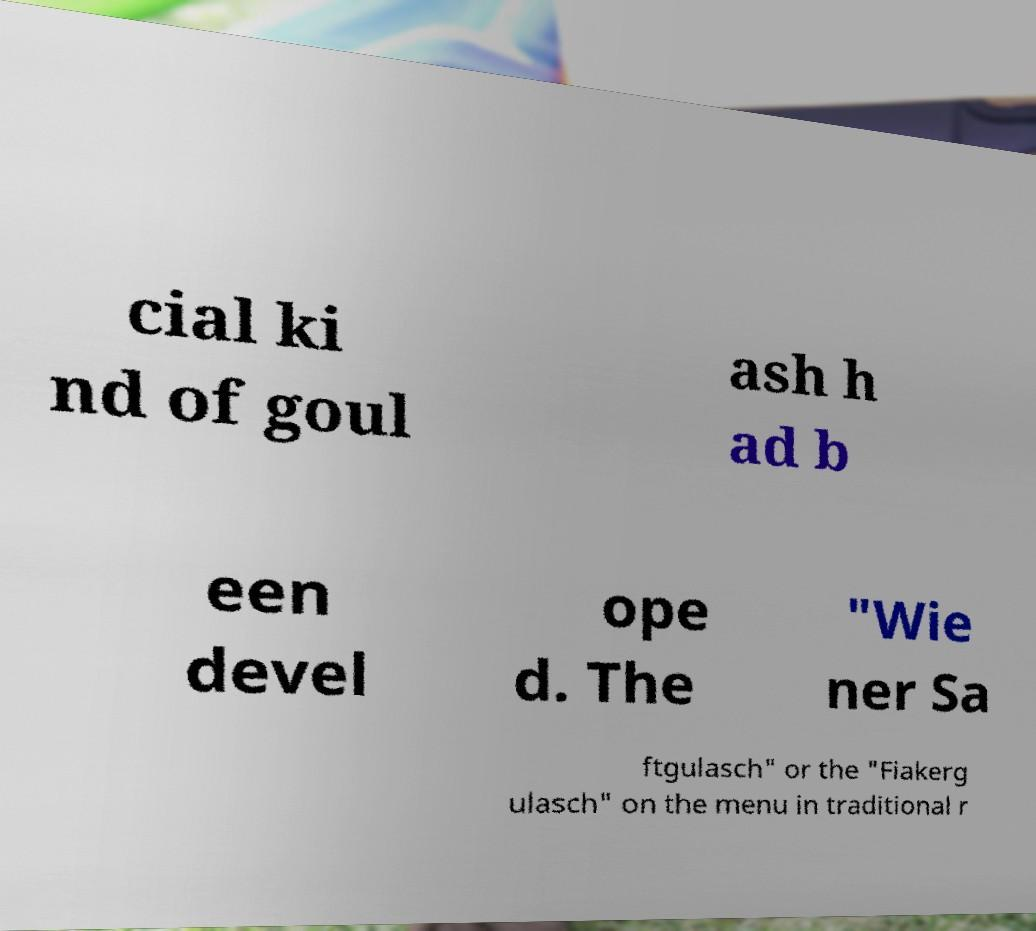I need the written content from this picture converted into text. Can you do that? cial ki nd of goul ash h ad b een devel ope d. The "Wie ner Sa ftgulasch" or the "Fiakerg ulasch" on the menu in traditional r 